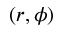Convert formula to latex. <formula><loc_0><loc_0><loc_500><loc_500>( r , \phi )</formula> 